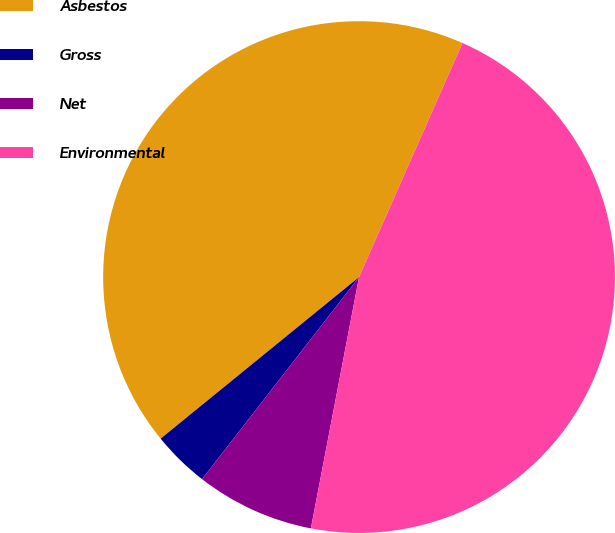Convert chart to OTSL. <chart><loc_0><loc_0><loc_500><loc_500><pie_chart><fcel>Asbestos<fcel>Gross<fcel>Net<fcel>Environmental<nl><fcel>42.5%<fcel>3.61%<fcel>7.5%<fcel>46.39%<nl></chart> 